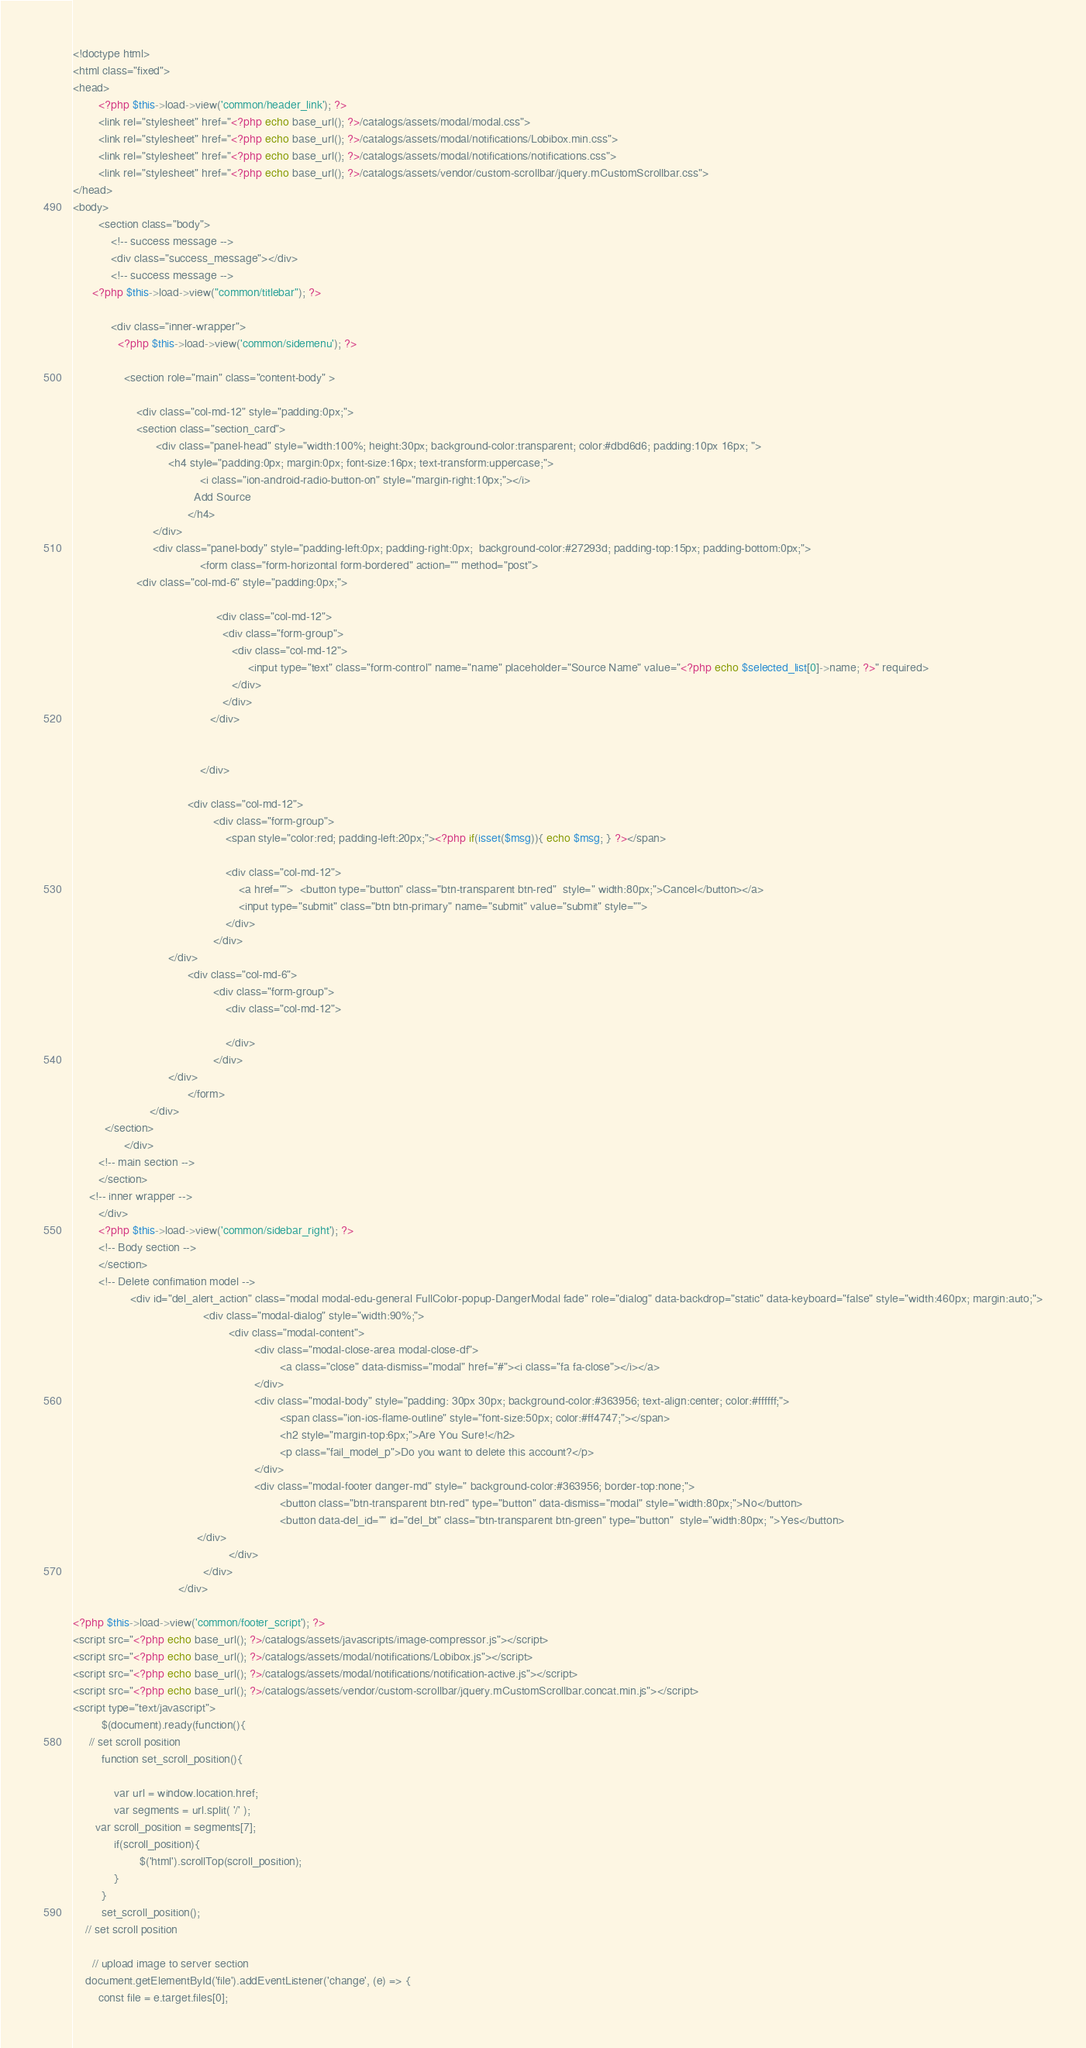<code> <loc_0><loc_0><loc_500><loc_500><_PHP_><!doctype html>
<html class="fixed">
<head>
		<?php $this->load->view('common/header_link'); ?>
		<link rel="stylesheet" href="<?php echo base_url(); ?>/catalogs/assets/modal/modal.css">
		<link rel="stylesheet" href="<?php echo base_url(); ?>/catalogs/assets/modal/notifications/Lobibox.min.css">
		<link rel="stylesheet" href="<?php echo base_url(); ?>/catalogs/assets/modal/notifications/notifications.css">
		<link rel="stylesheet" href="<?php echo base_url(); ?>/catalogs/assets/vendor/custom-scrollbar/jquery.mCustomScrollbar.css">
</head>
<body>
		<section class="body">
			<!-- success message -->
			<div class="success_message"></div>
			<!-- success message -->
      <?php $this->load->view("common/titlebar"); ?>

			<div class="inner-wrapper">
			  <?php $this->load->view('common/sidemenu'); ?>

				<section role="main" class="content-body" >

					<div class="col-md-12" style="padding:0px;">
					<section class="section_card">
						  <div class="panel-head" style="width:100%; height:30px; background-color:transparent; color:#dbd6d6; padding:10px 16px; ">
						      <h4 style="padding:0px; margin:0px; font-size:16px; text-transform:uppercase;">
										<i class="ion-android-radio-button-on" style="margin-right:10px;"></i>
									  Add Source
									</h4>
						 </div>
						 <div class="panel-body" style="padding-left:0px; padding-right:0px;  background-color:#27293d; padding-top:15px; padding-bottom:0px;">
										<form class="form-horizontal form-bordered" action="" method="post">
                    <div class="col-md-6" style="padding:0px;">

											 <div class="col-md-12">
											   <div class="form-group">
												  <div class="col-md-12">
													   <input type="text" class="form-control" name="name" placeholder="Source Name" value="<?php echo $selected_list[0]->name; ?>" required>
												  </div>
											   </div>
										   </div>
											
										
										</div>
                                      
									<div class="col-md-12">
											<div class="form-group">
                                                <span style="color:red; padding-left:20px;"><?php if(isset($msg)){ echo $msg; } ?></span>
                                                
												<div class="col-md-12">
													<a href="">	<button type="button" class="btn-transparent btn-red"  style=" width:80px;">Cancel</button></a>
													<input type="submit" class="btn btn-primary" name="submit" value="submit" style="">
												</div>
											</div>
						      </div>
									<div class="col-md-6">
											<div class="form-group">
												<div class="col-md-12">

												</div>
											</div>
						      </div>
									</form>
						</div>
          </section>
				</div>
		<!-- main section -->
        </section>
	 <!-- inner wrapper -->
		</div>
		<?php $this->load->view('common/sidebar_right'); ?>
		<!-- Body section -->
		</section>
		<!-- Delete confimation model -->
		          <div id="del_alert_action" class="modal modal-edu-general FullColor-popup-DangerModal fade" role="dialog" data-backdrop="static" data-keyboard="false" style="width:460px; margin:auto;">
										 <div class="modal-dialog" style="width:90%;">
												 <div class="modal-content">
														 <div class="modal-close-area modal-close-df">
																 <a class="close" data-dismiss="modal" href="#"><i class="fa fa-close"></i></a>
														 </div>
														 <div class="modal-body" style="padding: 30px 30px; background-color:#363956; text-align:center; color:#ffffff;">
																 <span class="ion-ios-flame-outline" style="font-size:50px; color:#ff4747;"></span>
																 <h2 style="margin-top:6px;">Are You Sure!</h2>
																 <p class="fail_model_p">Do you want to delete this account?</p>
														 </div>
														 <div class="modal-footer danger-md" style=" background-color:#363956; border-top:none;">
																 <button class="btn-transparent btn-red" type="button" data-dismiss="modal" style="width:80px;">No</button>
																 <button data-del_id="" id="del_bt" class="btn-transparent btn-green" type="button"  style="width:80px; ">Yes</button>
					                   </div>
												 </div>
										 </div>
								 </div>

<?php $this->load->view('common/footer_script'); ?>
<script src="<?php echo base_url(); ?>/catalogs/assets/javascripts/image-compressor.js"></script>
<script src="<?php echo base_url(); ?>/catalogs/assets/modal/notifications/Lobibox.js"></script>
<script src="<?php echo base_url(); ?>/catalogs/assets/modal/notifications/notification-active.js"></script>
<script src="<?php echo base_url(); ?>/catalogs/assets/vendor/custom-scrollbar/jquery.mCustomScrollbar.concat.min.js"></script>
<script type="text/javascript">
		 $(document).ready(function(){
     // set scroll position
		 function set_scroll_position(){

			 var url = window.location.href;
			 var segments = url.split( '/' );
       var scroll_position = segments[7];
			 if(scroll_position){
					 $('html').scrollTop(scroll_position);
			 }
		 }
		 set_scroll_position();
    // set scroll position

	  // upload image to server section
    document.getElementById('file').addEventListener('change', (e) => {
        const file = e.target.files[0];</code> 